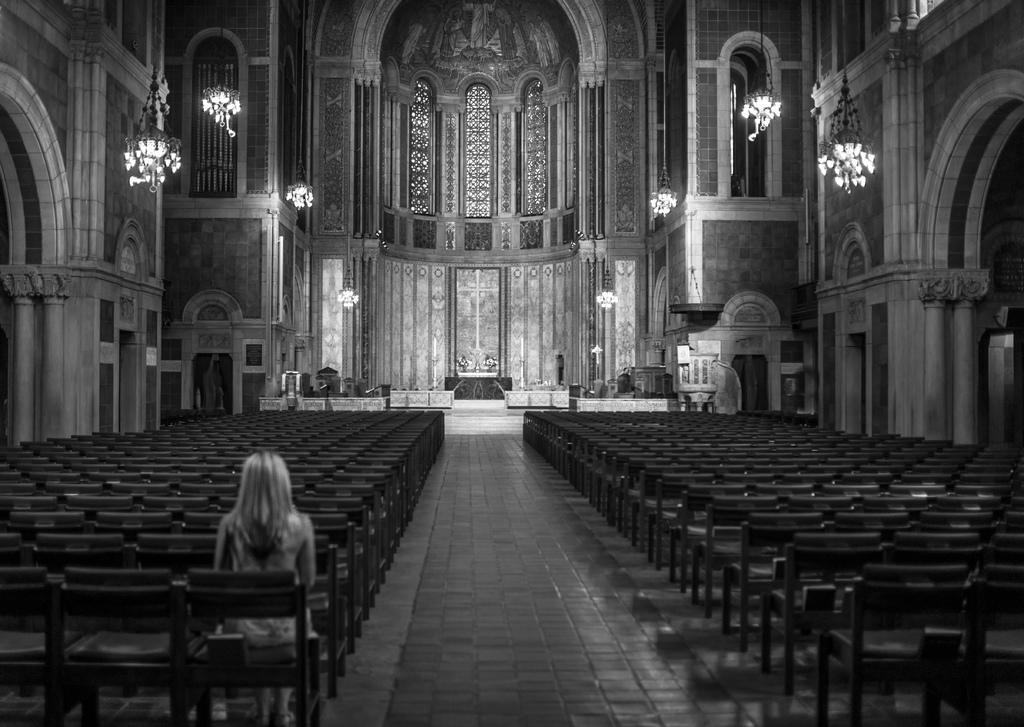Describe this image in one or two sentences. In this image i can see a woman sitting on a chair and a number of empty chairs. In the background i can see the interior of the building, few lights and the wall. 